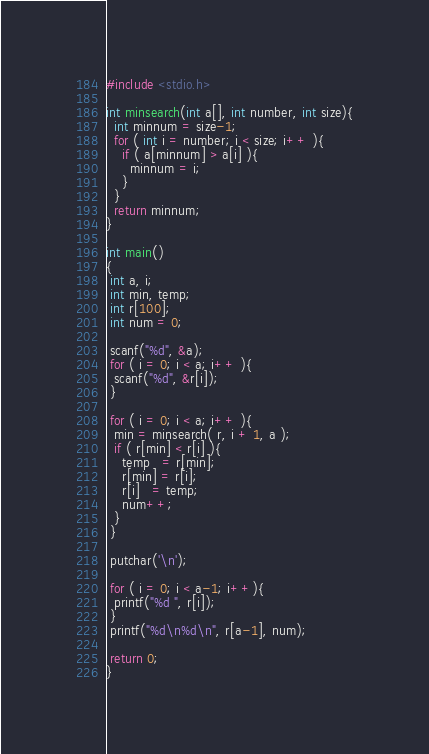Convert code to text. <code><loc_0><loc_0><loc_500><loc_500><_C_>#include <stdio.h>

int minsearch(int a[], int number, int size){
  int minnum = size-1;
  for ( int i = number; i < size; i++ ){
    if ( a[minnum] > a[i] ){
      minnum = i;
    }
  }
  return minnum;
}

int main()
{
 int a, i;
 int min, temp;
 int r[100];
 int num = 0;

 scanf("%d", &a);
 for ( i = 0; i < a; i++ ){
  scanf("%d", &r[i]);
 }

 for ( i = 0; i < a; i++ ){
  min = minsearch( r, i + 1, a );
  if ( r[min] < r[i] ){
    temp   = r[min];
    r[min] = r[i];
    r[i]   = temp;
    num++;
  }
 }

 putchar('\n');

 for ( i = 0; i < a-1; i++){
  printf("%d ", r[i]);
 }
 printf("%d\n%d\n", r[a-1], num);

 return 0;
}

</code> 